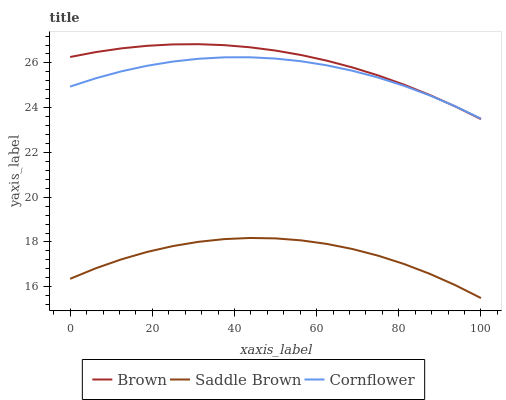Does Saddle Brown have the minimum area under the curve?
Answer yes or no. Yes. Does Brown have the maximum area under the curve?
Answer yes or no. Yes. Does Cornflower have the minimum area under the curve?
Answer yes or no. No. Does Cornflower have the maximum area under the curve?
Answer yes or no. No. Is Brown the smoothest?
Answer yes or no. Yes. Is Saddle Brown the roughest?
Answer yes or no. Yes. Is Cornflower the smoothest?
Answer yes or no. No. Is Cornflower the roughest?
Answer yes or no. No. Does Saddle Brown have the lowest value?
Answer yes or no. Yes. Does Cornflower have the lowest value?
Answer yes or no. No. Does Brown have the highest value?
Answer yes or no. Yes. Does Cornflower have the highest value?
Answer yes or no. No. Is Saddle Brown less than Brown?
Answer yes or no. Yes. Is Cornflower greater than Saddle Brown?
Answer yes or no. Yes. Does Cornflower intersect Brown?
Answer yes or no. Yes. Is Cornflower less than Brown?
Answer yes or no. No. Is Cornflower greater than Brown?
Answer yes or no. No. Does Saddle Brown intersect Brown?
Answer yes or no. No. 